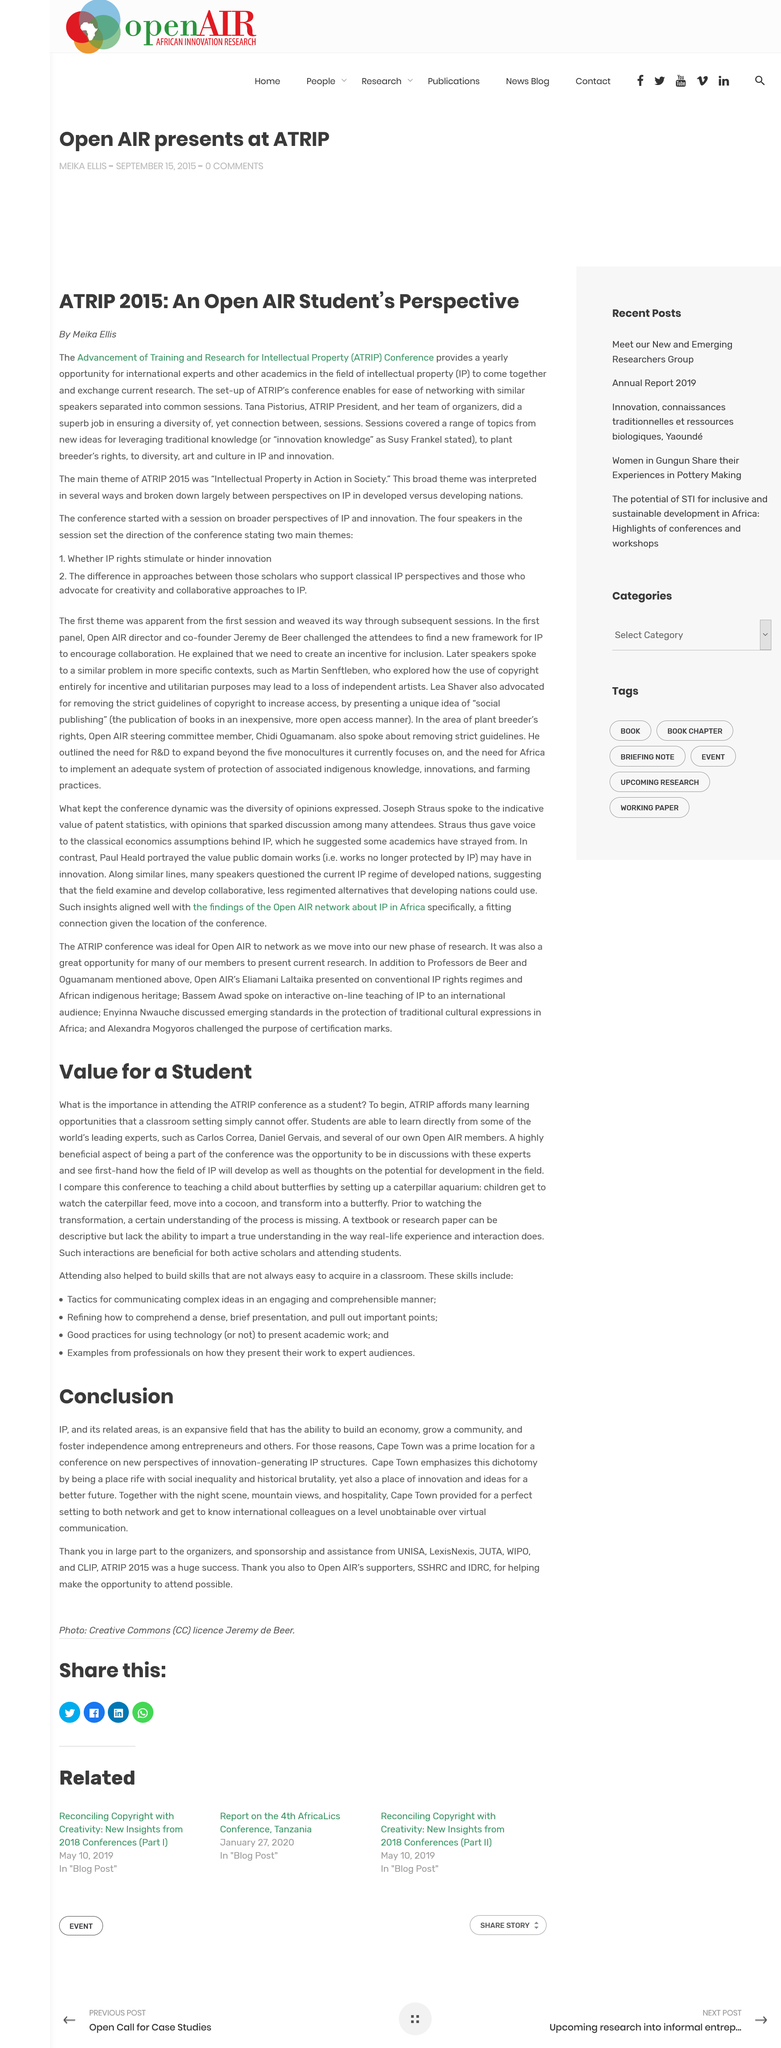Indicate a few pertinent items in this graphic. The conference was held in Cape Town. It was impossible to get to know my international colleagues through virtual communication as it was unobtainable. Meika Ellis published "ARTIP 2015: An AIR Students Perspective" in 2015. The ATRIP Conference is an annual event that brings together international experts and scholars in the field of intellectual property to share and discuss their latest research findings. IP is not a small field, but rather an expansive one. 